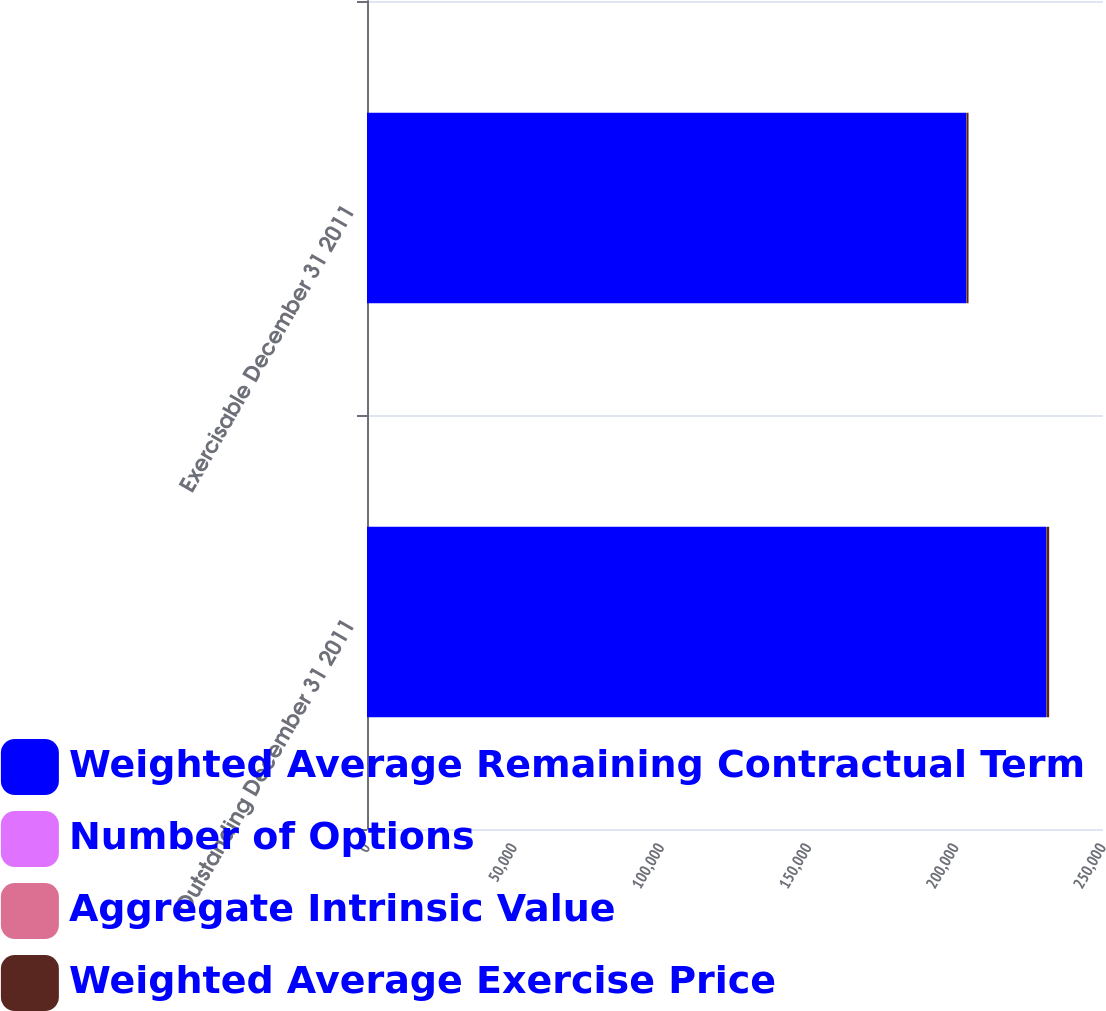Convert chart. <chart><loc_0><loc_0><loc_500><loc_500><stacked_bar_chart><ecel><fcel>Outstanding December 31 2011<fcel>Exercisable December 31 2011<nl><fcel>Weighted Average Remaining Contractual Term<fcel>230760<fcel>203573<nl><fcel>Number of Options<fcel>39.51<fcel>40.67<nl><fcel>Aggregate Intrinsic Value<fcel>4.11<fcel>3.67<nl><fcel>Weighted Average Exercise Price<fcel>910<fcel>706<nl></chart> 